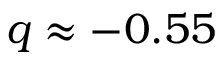<formula> <loc_0><loc_0><loc_500><loc_500>q \approx - 0 . 5 5</formula> 